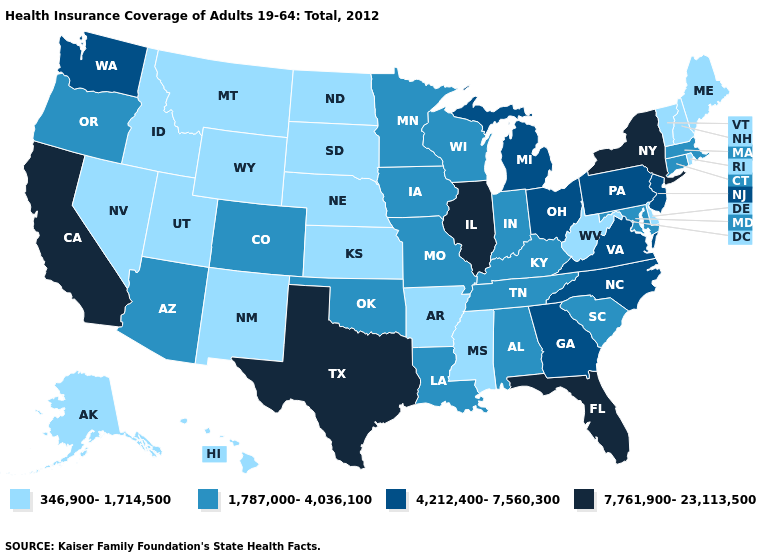Does Montana have the same value as New Jersey?
Give a very brief answer. No. What is the highest value in the USA?
Be succinct. 7,761,900-23,113,500. What is the highest value in the USA?
Write a very short answer. 7,761,900-23,113,500. Does Ohio have the same value as Kentucky?
Quick response, please. No. Which states hav the highest value in the MidWest?
Concise answer only. Illinois. What is the highest value in the USA?
Short answer required. 7,761,900-23,113,500. Name the states that have a value in the range 1,787,000-4,036,100?
Concise answer only. Alabama, Arizona, Colorado, Connecticut, Indiana, Iowa, Kentucky, Louisiana, Maryland, Massachusetts, Minnesota, Missouri, Oklahoma, Oregon, South Carolina, Tennessee, Wisconsin. Name the states that have a value in the range 4,212,400-7,560,300?
Be succinct. Georgia, Michigan, New Jersey, North Carolina, Ohio, Pennsylvania, Virginia, Washington. What is the highest value in the USA?
Write a very short answer. 7,761,900-23,113,500. Does Idaho have the lowest value in the USA?
Be succinct. Yes. What is the value of Virginia?
Write a very short answer. 4,212,400-7,560,300. Which states hav the highest value in the Northeast?
Give a very brief answer. New York. Does Montana have the highest value in the West?
Keep it brief. No. Name the states that have a value in the range 4,212,400-7,560,300?
Be succinct. Georgia, Michigan, New Jersey, North Carolina, Ohio, Pennsylvania, Virginia, Washington. 